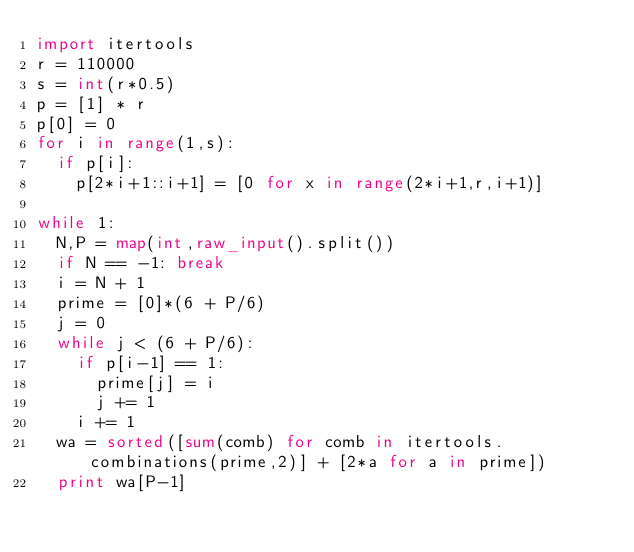<code> <loc_0><loc_0><loc_500><loc_500><_Python_>import itertools
r = 110000
s = int(r*0.5)
p = [1] * r
p[0] = 0
for i in range(1,s):
	if p[i]:
		p[2*i+1::i+1] = [0 for x in range(2*i+1,r,i+1)]
		
while 1:
	N,P = map(int,raw_input().split())
	if N == -1: break
	i = N + 1
	prime = [0]*(6 + P/6)
	j = 0
	while j < (6 + P/6):
		if p[i-1] == 1:
			prime[j] = i
			j += 1
		i += 1
	wa = sorted([sum(comb) for comb in itertools.combinations(prime,2)] + [2*a for a in prime])
	print wa[P-1]</code> 